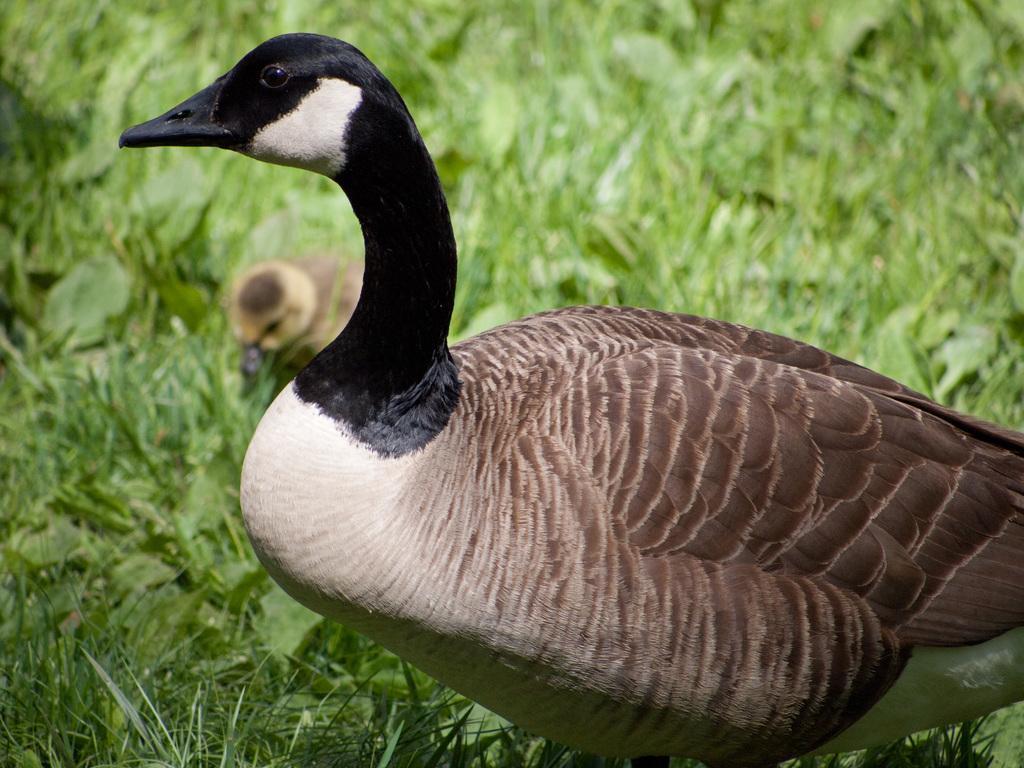In one or two sentences, can you explain what this image depicts? In this image we can see a duck and a duckling on the grass. 